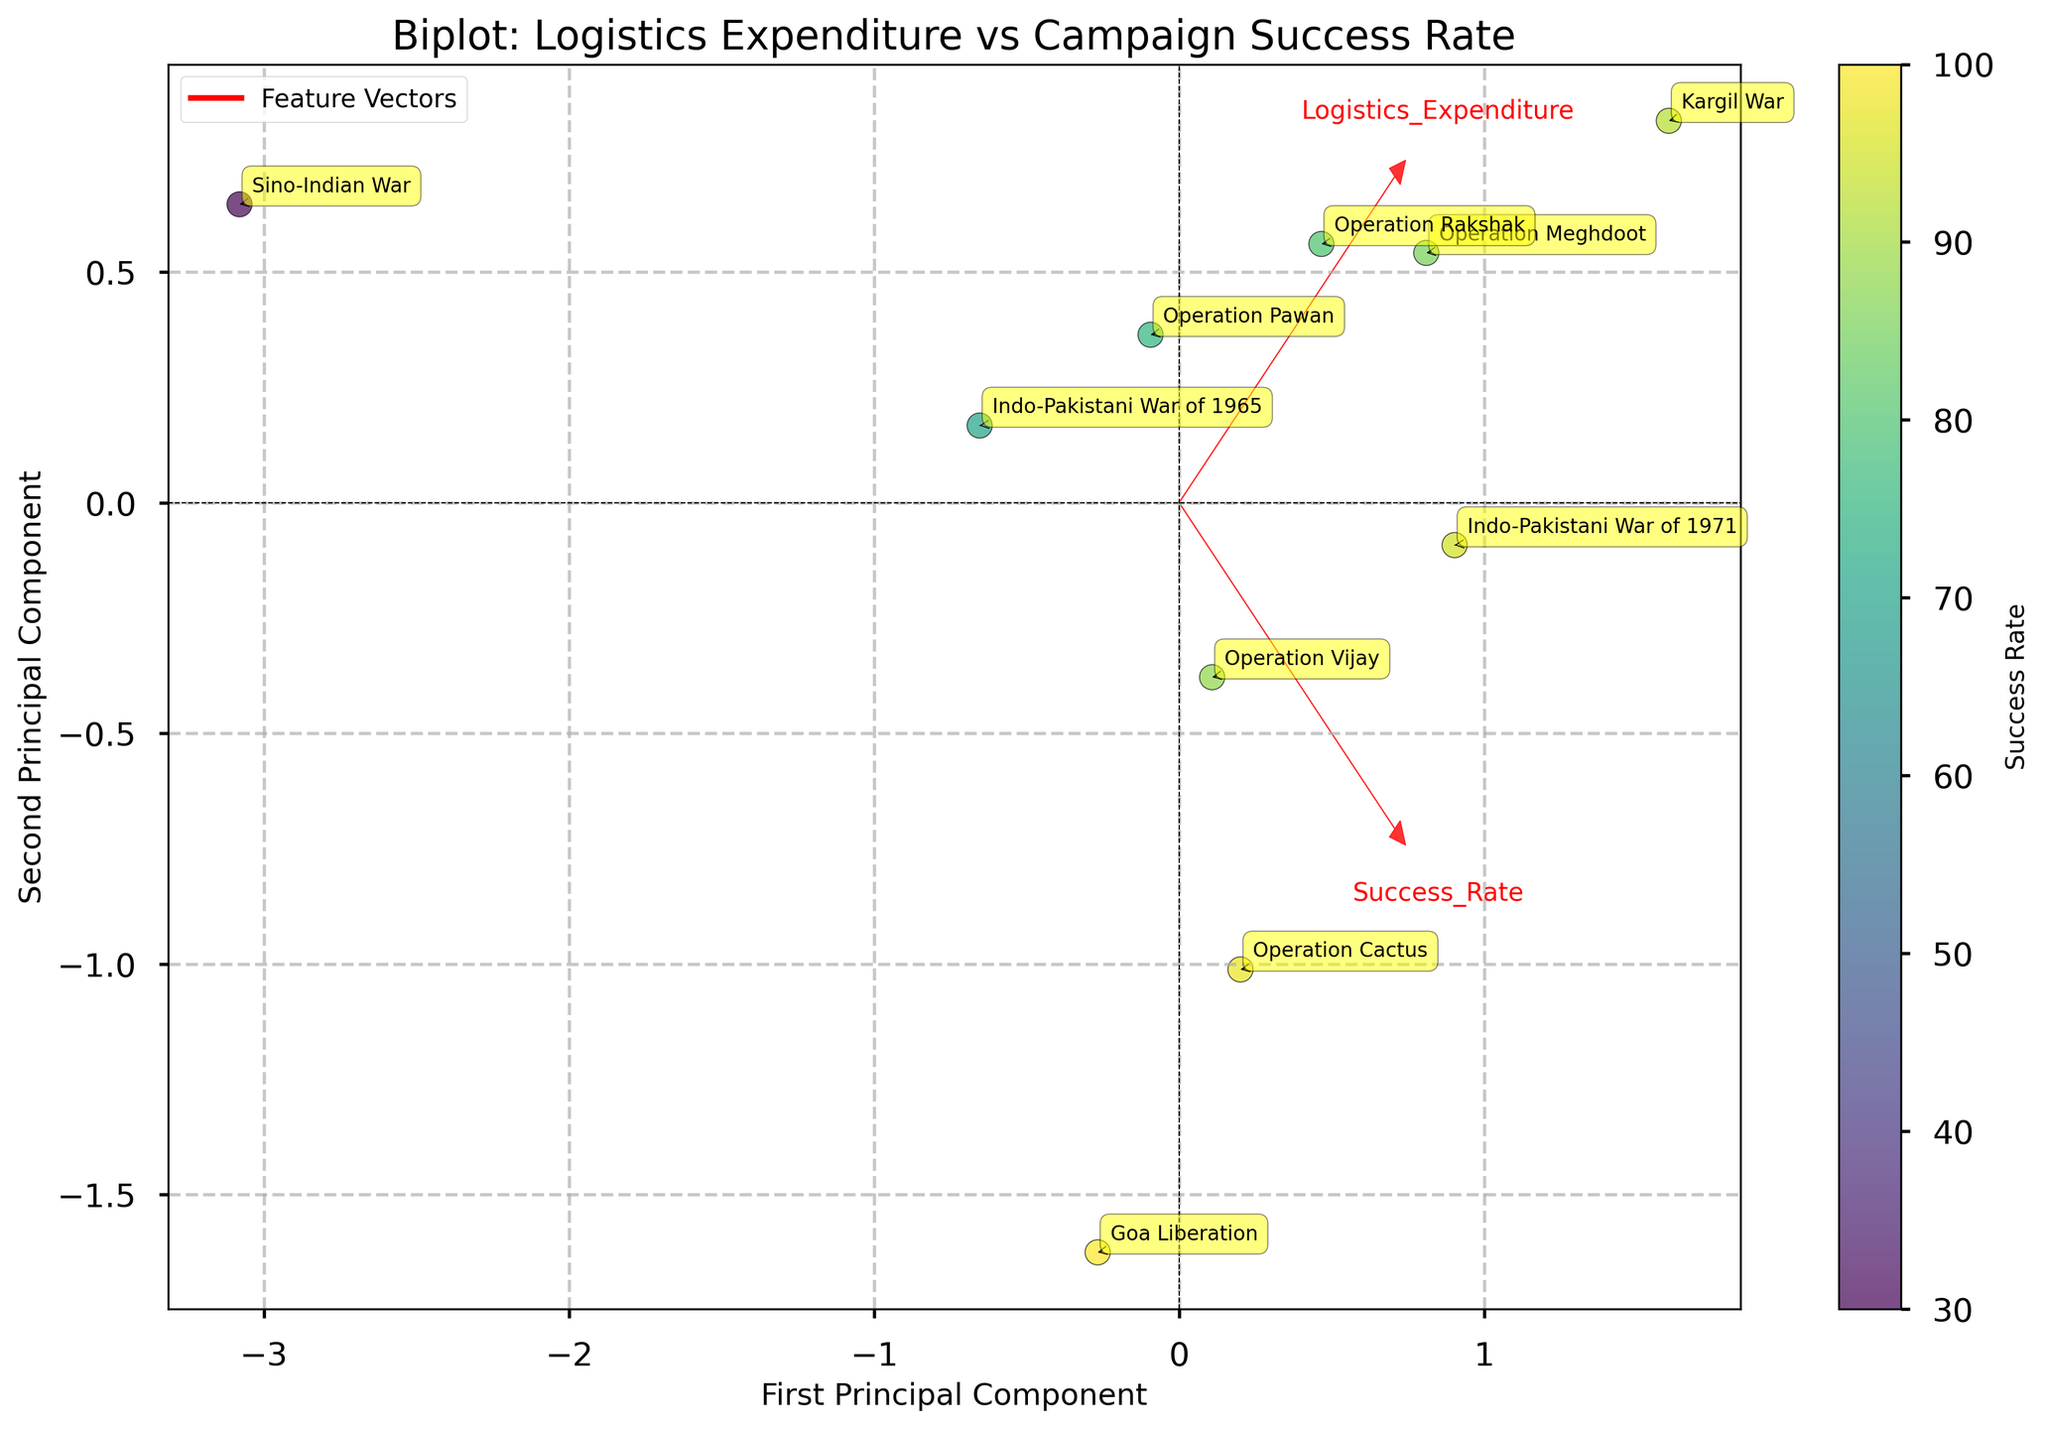What is the title of the biplot? The title of the plot is usually located at the top of the figure and is often written in larger, bold text. In this case, it reads 'Biplot: Logistics Expenditure vs Campaign Success Rate'.
Answer: Biplot: Logistics Expenditure vs Campaign Success Rate How many Indian military campaigns are shown in the biplot? Each data point represents one campaign, and the plot annotations will help identify them by name. By counting the annotations, we find there are 10 campaigns.
Answer: 10 Which campaign has the highest success rate, as indicated by color intensity? The colorbar on the right of the plot indicates that a higher success rate is represented by a more intense color (e.g., yellow). The campaign "Goa Liberation" is likely represented by the point with the highest intensity.
Answer: Goa Liberation Where is the 'Sino-Indian War' positioned concerning the principal components? Look for the annotation 'Sino-Indian War' on the plot and note its coordinates along the first and second principal components. According to the plot, it is positioned in the lower-left quadrant.
Answer: Lower-left quadrant Which campaigns have ongoing durations? Ongoing campaigns are indicated by the label "Ongoing" in the data. Look at the plot for the campaigns annotated as "Operation Meghdoot" and "Operation Rakshak".
Answer: Operation Meghdoot and Operation Rakshak Between 'Kargil War' and 'Indo-Pakistani War of 1965', which has a higher logistics expenditure? By finding the respective campaign labels on the plot and observing their positions, 'Kargil War' appears further along the principal component associated with higher logistics expenditure.
Answer: Kargil War Identify the two campaigns with the closest proximity in the biplot. By visually inspecting the distances between the points, the 'Indo-Pakistani War of 1965' and 'Operation Pawan' appear to be positioned closest to each other.
Answer: Indo-Pakistani War of 1965 and Operation Pawan Which feature (logistics expenditure or success rate) is more strongly correlated with the first principal component? Feature vectors' arrows indicate the strength and direction of the features with the principal components. The arrow representing 'Logistics Expenditure' aligns more closely with the first principal component.
Answer: Logistics Expenditure Is 'Operation Cactus' characterized by high or low logistics expenditure relative to other campaigns? Locate 'Operation Cactus' on the biplot and analyze its position against the principal component associated with logistics expenditure. Its position suggests it has a moderate expenditure compared to others.
Answer: Moderate What is the relative orientation of 'Operation Vijay' compared to the 'Indo-Pakistani War of 1971'? Find the campaigns on the biplot; 'Operation Vijay' is generally to the left and slightly below 'Indo-Pakistani War of 1971,' indicating differences in logistics expenditure and success rate.
Answer: Left and slightly below 